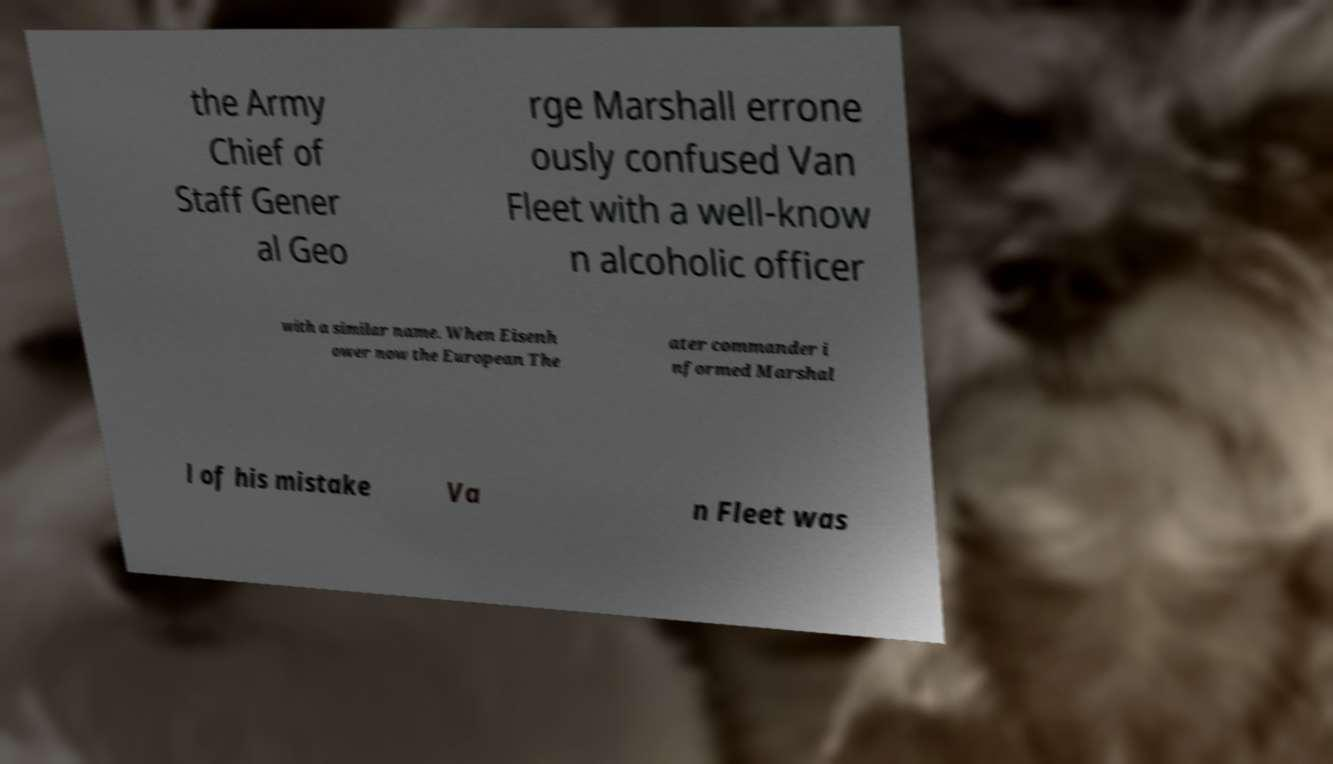Please identify and transcribe the text found in this image. the Army Chief of Staff Gener al Geo rge Marshall errone ously confused Van Fleet with a well-know n alcoholic officer with a similar name. When Eisenh ower now the European The ater commander i nformed Marshal l of his mistake Va n Fleet was 